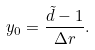Convert formula to latex. <formula><loc_0><loc_0><loc_500><loc_500>y _ { 0 } = \frac { \tilde { d } - 1 } { \Delta r } .</formula> 